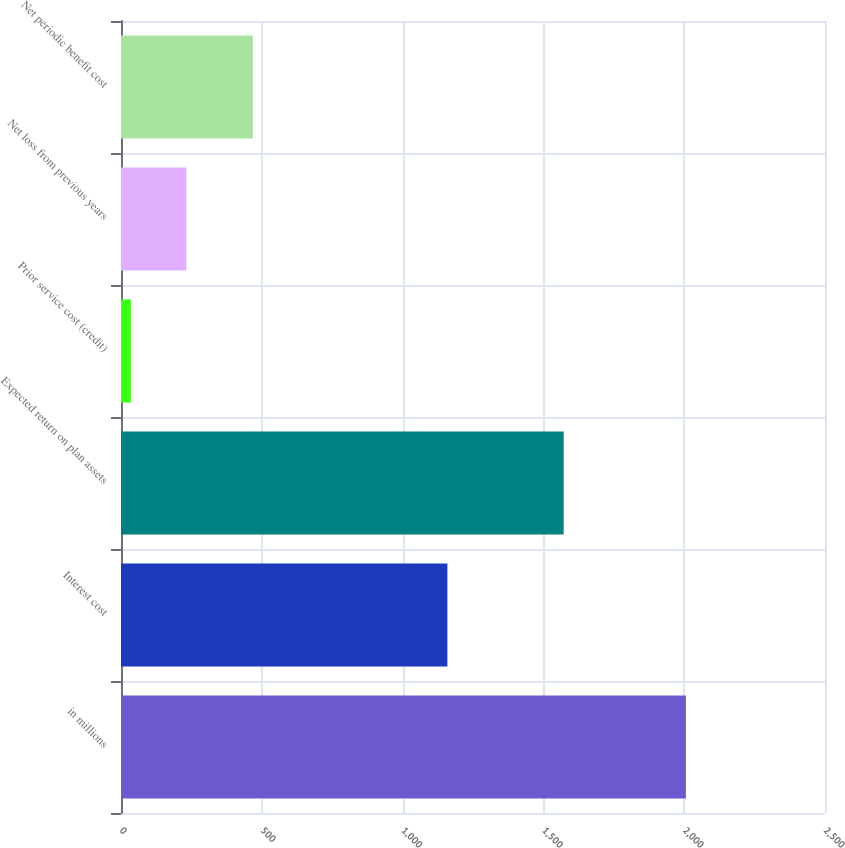Convert chart to OTSL. <chart><loc_0><loc_0><loc_500><loc_500><bar_chart><fcel>in millions<fcel>Interest cost<fcel>Expected return on plan assets<fcel>Prior service cost (credit)<fcel>Net loss from previous years<fcel>Net periodic benefit cost<nl><fcel>2006<fcel>1159<fcel>1572<fcel>35<fcel>232.1<fcel>468<nl></chart> 